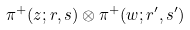<formula> <loc_0><loc_0><loc_500><loc_500>\pi ^ { + } ( z ; r , s ) \otimes \pi ^ { + } ( w ; r ^ { \prime } , s ^ { \prime } )</formula> 